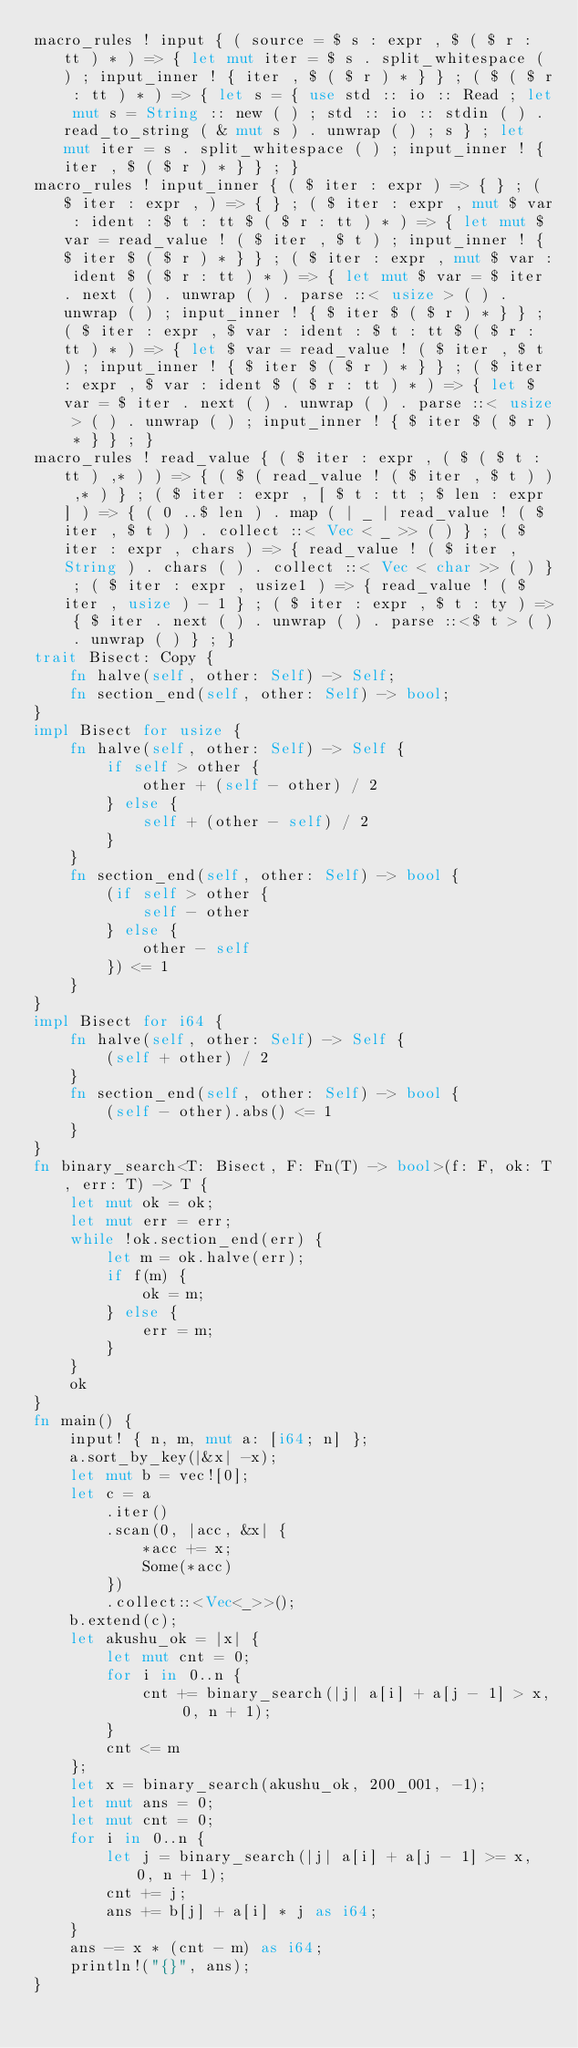Convert code to text. <code><loc_0><loc_0><loc_500><loc_500><_Rust_>macro_rules ! input { ( source = $ s : expr , $ ( $ r : tt ) * ) => { let mut iter = $ s . split_whitespace ( ) ; input_inner ! { iter , $ ( $ r ) * } } ; ( $ ( $ r : tt ) * ) => { let s = { use std :: io :: Read ; let mut s = String :: new ( ) ; std :: io :: stdin ( ) . read_to_string ( & mut s ) . unwrap ( ) ; s } ; let mut iter = s . split_whitespace ( ) ; input_inner ! { iter , $ ( $ r ) * } } ; }
macro_rules ! input_inner { ( $ iter : expr ) => { } ; ( $ iter : expr , ) => { } ; ( $ iter : expr , mut $ var : ident : $ t : tt $ ( $ r : tt ) * ) => { let mut $ var = read_value ! ( $ iter , $ t ) ; input_inner ! { $ iter $ ( $ r ) * } } ; ( $ iter : expr , mut $ var : ident $ ( $ r : tt ) * ) => { let mut $ var = $ iter . next ( ) . unwrap ( ) . parse ::< usize > ( ) . unwrap ( ) ; input_inner ! { $ iter $ ( $ r ) * } } ; ( $ iter : expr , $ var : ident : $ t : tt $ ( $ r : tt ) * ) => { let $ var = read_value ! ( $ iter , $ t ) ; input_inner ! { $ iter $ ( $ r ) * } } ; ( $ iter : expr , $ var : ident $ ( $ r : tt ) * ) => { let $ var = $ iter . next ( ) . unwrap ( ) . parse ::< usize > ( ) . unwrap ( ) ; input_inner ! { $ iter $ ( $ r ) * } } ; }
macro_rules ! read_value { ( $ iter : expr , ( $ ( $ t : tt ) ,* ) ) => { ( $ ( read_value ! ( $ iter , $ t ) ) ,* ) } ; ( $ iter : expr , [ $ t : tt ; $ len : expr ] ) => { ( 0 ..$ len ) . map ( | _ | read_value ! ( $ iter , $ t ) ) . collect ::< Vec < _ >> ( ) } ; ( $ iter : expr , chars ) => { read_value ! ( $ iter , String ) . chars ( ) . collect ::< Vec < char >> ( ) } ; ( $ iter : expr , usize1 ) => { read_value ! ( $ iter , usize ) - 1 } ; ( $ iter : expr , $ t : ty ) => { $ iter . next ( ) . unwrap ( ) . parse ::<$ t > ( ) . unwrap ( ) } ; }
trait Bisect: Copy {
    fn halve(self, other: Self) -> Self;
    fn section_end(self, other: Self) -> bool;
}
impl Bisect for usize {
    fn halve(self, other: Self) -> Self {
        if self > other {
            other + (self - other) / 2
        } else {
            self + (other - self) / 2
        }
    }
    fn section_end(self, other: Self) -> bool {
        (if self > other {
            self - other
        } else {
            other - self
        }) <= 1
    }
}
impl Bisect for i64 {
    fn halve(self, other: Self) -> Self {
        (self + other) / 2
    }
    fn section_end(self, other: Self) -> bool {
        (self - other).abs() <= 1
    }
}
fn binary_search<T: Bisect, F: Fn(T) -> bool>(f: F, ok: T, err: T) -> T {
    let mut ok = ok;
    let mut err = err;
    while !ok.section_end(err) {
        let m = ok.halve(err);
        if f(m) {
            ok = m;
        } else {
            err = m;
        }
    }
    ok
}
fn main() {
    input! { n, m, mut a: [i64; n] };
    a.sort_by_key(|&x| -x);
    let mut b = vec![0];
    let c = a
        .iter()
        .scan(0, |acc, &x| {
            *acc += x;
            Some(*acc)
        })
        .collect::<Vec<_>>();
    b.extend(c);
    let akushu_ok = |x| {
        let mut cnt = 0;
        for i in 0..n {
            cnt += binary_search(|j| a[i] + a[j - 1] > x, 0, n + 1);
        }
        cnt <= m
    };
    let x = binary_search(akushu_ok, 200_001, -1);
    let mut ans = 0;
    let mut cnt = 0;
    for i in 0..n {
        let j = binary_search(|j| a[i] + a[j - 1] >= x, 0, n + 1);
        cnt += j;
        ans += b[j] + a[i] * j as i64;
    }
    ans -= x * (cnt - m) as i64;
    println!("{}", ans);
}
</code> 